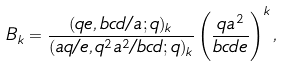<formula> <loc_0><loc_0><loc_500><loc_500>B _ { k } = \frac { ( q e , b c d / a ; q ) _ { k } } { ( a q / e , q ^ { 2 } a ^ { 2 } / b c d ; q ) _ { k } } \left ( \frac { q a ^ { 2 } } { b c d e } \right ) ^ { k } ,</formula> 